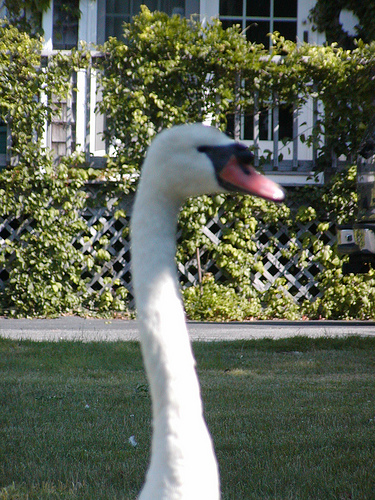<image>
Is the plant behind the bird? Yes. From this viewpoint, the plant is positioned behind the bird, with the bird partially or fully occluding the plant. 